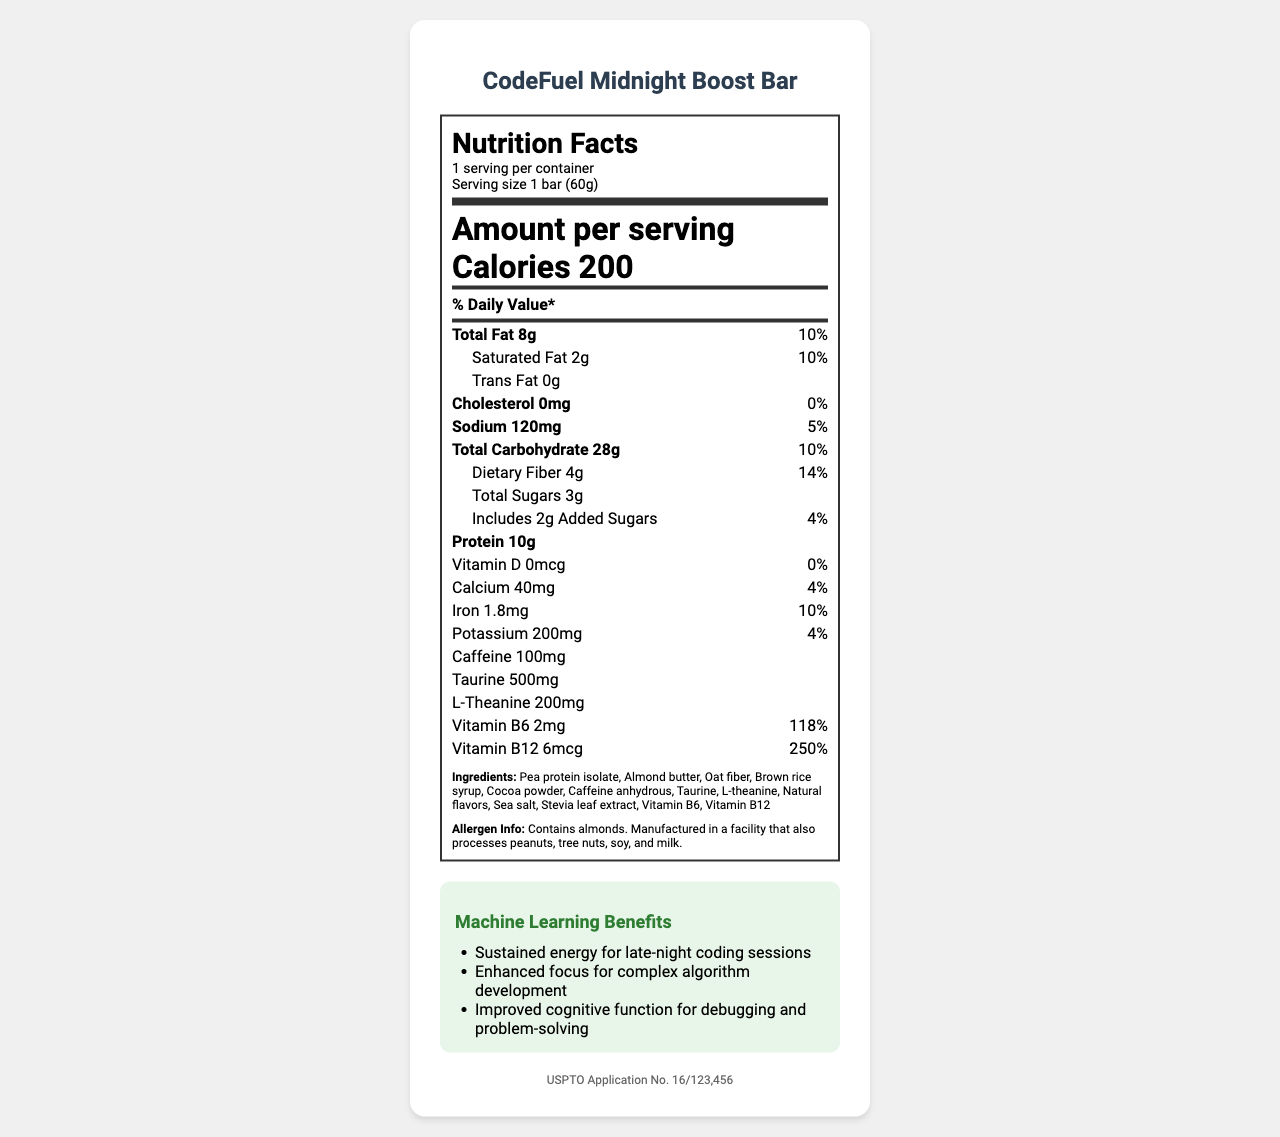What is the serving size of the CodeFuel Midnight Boost Bar? The serving size is specifically mentioned in the document under the serving information section.
Answer: 1 bar (60g) How many calories does one serving of the CodeFuel Midnight Boost Bar contain? The calorie content is clearly listed under the “Amount per serving” section.
Answer: 200 How much total fat is in one CodeFuel Midnight Boost Bar? The amount of total fat is specified in the nutrition facts under the "Total Fat" section.
Answer: 8g What percentage of the daily value comes from added sugars in one serving? The daily value percentage for added sugars is listed in the nutrition facts under the "Includes 2g Added Sugars" line.
Answer: 4% List all the ingredients in the CodeFuel Midnight Boost Bar. All the ingredients are provided at the end of the nutrition label in the ingredients section.
Answer: Pea protein isolate, Almond butter, Oat fiber, Brown rice syrup, Cocoa powder, Caffeine anhydrous, Taurine, L-theanine, Natural flavors, Sea salt, Stevia leaf extract, Vitamin B6, Vitamin B12 Which of these is a claim made about the CodeFuel Midnight Boost Bar? i. Low sugar ii. High protein iii. Gluten-free iv. Caffeine-infused The claims section lists "Low sugar", "High protein", and "Caffeine-infused". Gluten-free is not listed as a claim.
Answer: i, ii, and iv How much caffeine is present in one bar? A. 50mg B. 100mg C. 150mg D. 200mg The amount of caffeine in one bar is stated explicitly in the nutrient listing.
Answer: B. 100mg Does the CodeFuel Midnight Boost Bar contain any cholesterol? The document states that the bar contains 0mg of cholesterol.
Answer: No Is the CodeFuel Midnight Boost Bar vegan? The claims section explicitly mentions that the bar is vegan.
Answer: Yes Summarize the main idea of the CodeFuel Midnight Boost Bar’s nutrition facts label. This summary includes all main points and nutrition facts listed on the document, including calorie content, contributing nutrients, and special claims or benefits.
Answer: The CodeFuel Midnight Boost Bar is an energy bar designed for late-night coding sessions. It contains 200 calories per bar, with low sugar content (3g total, including 2g added sugars), high protein (10g), and 100mg of caffeine. The bar is vegan, non-GMO, and includes ingredients such as pea protein isolate, almond butter, and oat fiber. It also contains vitamins like B6 and B12, and provides benefits such as sustained energy and enhanced cognitive function for complex tasks. Which facility processes the CodeFuel Midnight Boost Bar? The document only states that the product is manufactured in a facility that processes peanuts, tree nuts, soy, and milk but does not specify the facility name or location.
Answer: Cannot be determined 